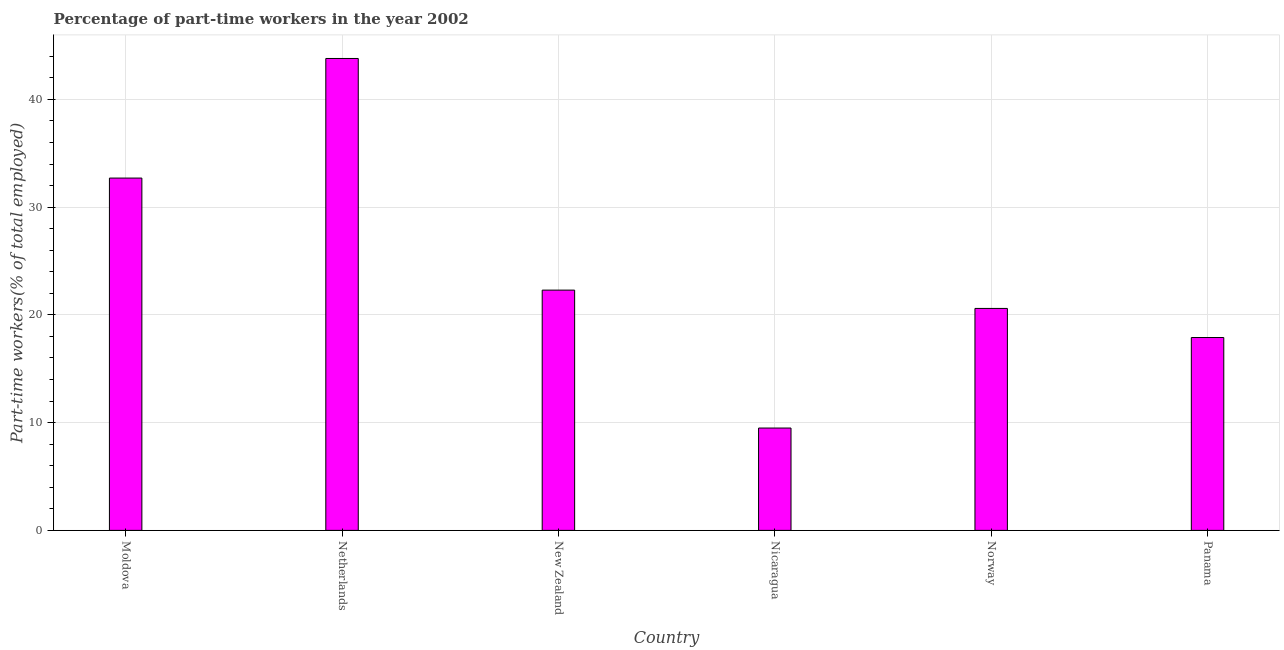Does the graph contain any zero values?
Provide a succinct answer. No. Does the graph contain grids?
Provide a succinct answer. Yes. What is the title of the graph?
Make the answer very short. Percentage of part-time workers in the year 2002. What is the label or title of the Y-axis?
Offer a very short reply. Part-time workers(% of total employed). What is the percentage of part-time workers in Moldova?
Your answer should be compact. 32.7. Across all countries, what is the maximum percentage of part-time workers?
Offer a terse response. 43.8. Across all countries, what is the minimum percentage of part-time workers?
Give a very brief answer. 9.5. In which country was the percentage of part-time workers maximum?
Provide a succinct answer. Netherlands. In which country was the percentage of part-time workers minimum?
Provide a succinct answer. Nicaragua. What is the sum of the percentage of part-time workers?
Your response must be concise. 146.8. What is the average percentage of part-time workers per country?
Your answer should be very brief. 24.47. What is the median percentage of part-time workers?
Keep it short and to the point. 21.45. What is the ratio of the percentage of part-time workers in Moldova to that in New Zealand?
Ensure brevity in your answer.  1.47. Is the sum of the percentage of part-time workers in Moldova and Panama greater than the maximum percentage of part-time workers across all countries?
Provide a succinct answer. Yes. What is the difference between the highest and the lowest percentage of part-time workers?
Offer a terse response. 34.3. How many bars are there?
Make the answer very short. 6. Are the values on the major ticks of Y-axis written in scientific E-notation?
Make the answer very short. No. What is the Part-time workers(% of total employed) of Moldova?
Provide a succinct answer. 32.7. What is the Part-time workers(% of total employed) in Netherlands?
Offer a very short reply. 43.8. What is the Part-time workers(% of total employed) of New Zealand?
Offer a terse response. 22.3. What is the Part-time workers(% of total employed) of Nicaragua?
Your answer should be very brief. 9.5. What is the Part-time workers(% of total employed) in Norway?
Provide a short and direct response. 20.6. What is the Part-time workers(% of total employed) of Panama?
Your answer should be very brief. 17.9. What is the difference between the Part-time workers(% of total employed) in Moldova and Nicaragua?
Keep it short and to the point. 23.2. What is the difference between the Part-time workers(% of total employed) in Moldova and Norway?
Offer a very short reply. 12.1. What is the difference between the Part-time workers(% of total employed) in Moldova and Panama?
Give a very brief answer. 14.8. What is the difference between the Part-time workers(% of total employed) in Netherlands and New Zealand?
Offer a terse response. 21.5. What is the difference between the Part-time workers(% of total employed) in Netherlands and Nicaragua?
Your response must be concise. 34.3. What is the difference between the Part-time workers(% of total employed) in Netherlands and Norway?
Make the answer very short. 23.2. What is the difference between the Part-time workers(% of total employed) in Netherlands and Panama?
Your response must be concise. 25.9. What is the difference between the Part-time workers(% of total employed) in New Zealand and Nicaragua?
Offer a terse response. 12.8. What is the difference between the Part-time workers(% of total employed) in New Zealand and Panama?
Make the answer very short. 4.4. What is the difference between the Part-time workers(% of total employed) in Nicaragua and Norway?
Ensure brevity in your answer.  -11.1. What is the ratio of the Part-time workers(% of total employed) in Moldova to that in Netherlands?
Provide a succinct answer. 0.75. What is the ratio of the Part-time workers(% of total employed) in Moldova to that in New Zealand?
Provide a short and direct response. 1.47. What is the ratio of the Part-time workers(% of total employed) in Moldova to that in Nicaragua?
Offer a very short reply. 3.44. What is the ratio of the Part-time workers(% of total employed) in Moldova to that in Norway?
Your response must be concise. 1.59. What is the ratio of the Part-time workers(% of total employed) in Moldova to that in Panama?
Your response must be concise. 1.83. What is the ratio of the Part-time workers(% of total employed) in Netherlands to that in New Zealand?
Your response must be concise. 1.96. What is the ratio of the Part-time workers(% of total employed) in Netherlands to that in Nicaragua?
Provide a short and direct response. 4.61. What is the ratio of the Part-time workers(% of total employed) in Netherlands to that in Norway?
Give a very brief answer. 2.13. What is the ratio of the Part-time workers(% of total employed) in Netherlands to that in Panama?
Make the answer very short. 2.45. What is the ratio of the Part-time workers(% of total employed) in New Zealand to that in Nicaragua?
Make the answer very short. 2.35. What is the ratio of the Part-time workers(% of total employed) in New Zealand to that in Norway?
Offer a very short reply. 1.08. What is the ratio of the Part-time workers(% of total employed) in New Zealand to that in Panama?
Provide a succinct answer. 1.25. What is the ratio of the Part-time workers(% of total employed) in Nicaragua to that in Norway?
Offer a very short reply. 0.46. What is the ratio of the Part-time workers(% of total employed) in Nicaragua to that in Panama?
Your response must be concise. 0.53. What is the ratio of the Part-time workers(% of total employed) in Norway to that in Panama?
Offer a terse response. 1.15. 